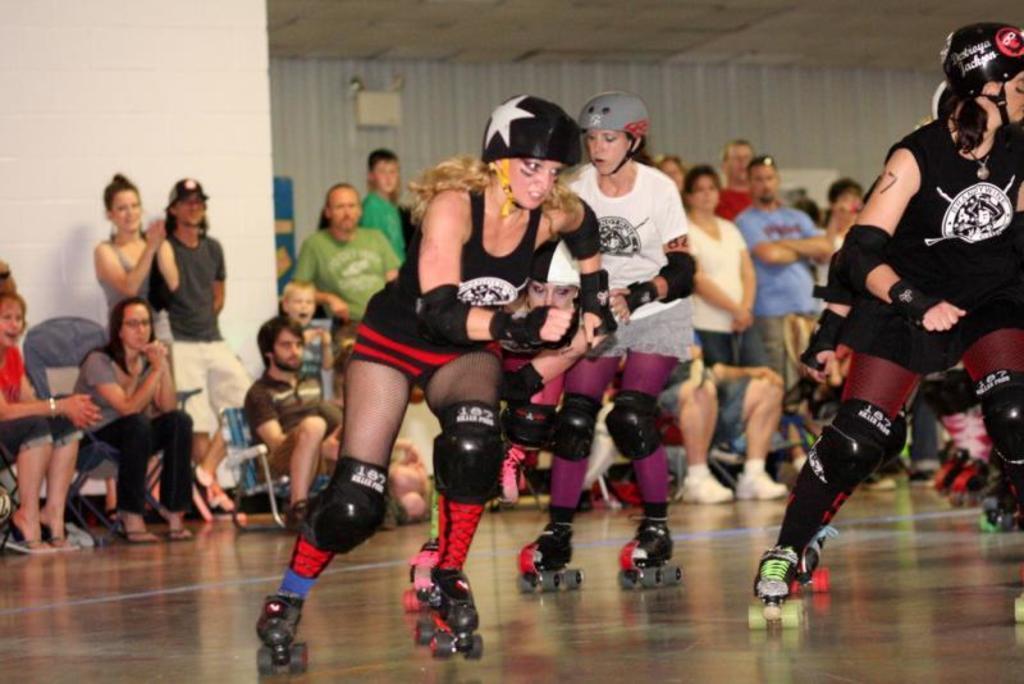How would you summarize this image in a sentence or two? In this picture we can see three persons skating here, they wore helmets, gloves and shoes, in the background there are some people standing and some people sitting here, we can see a wall here. 